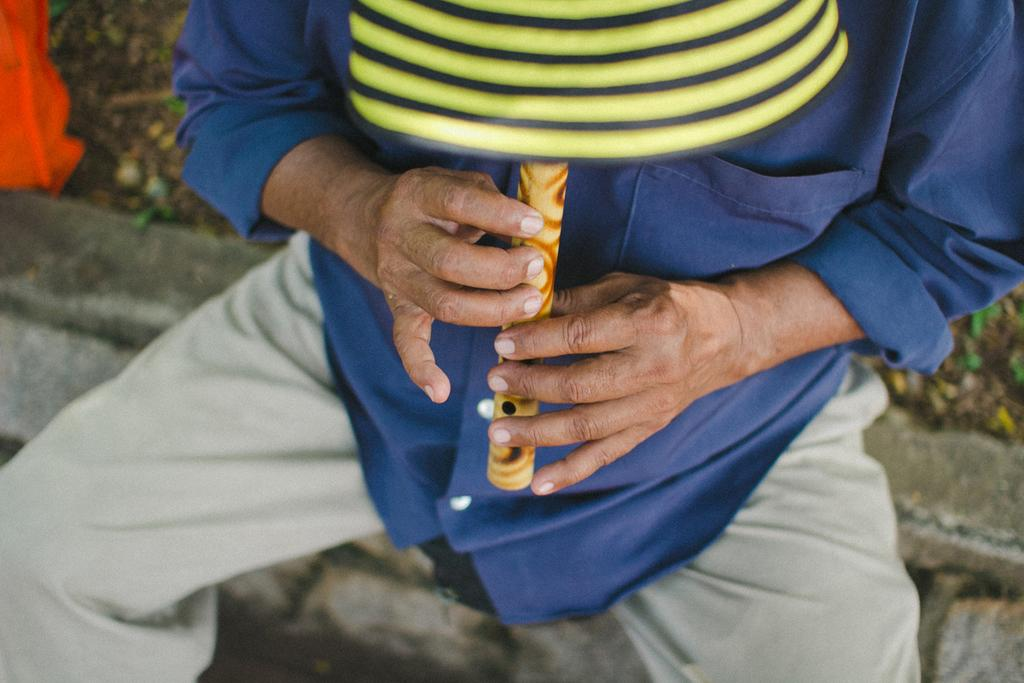What is the main subject of the image? There is a man in the center of the image. What is the man holding in his hands? The man is holding a flute in his hands. What type of paste is the man using to play the flute in the image? There is no paste present in the image, and the man is not using any paste to play the flute. 